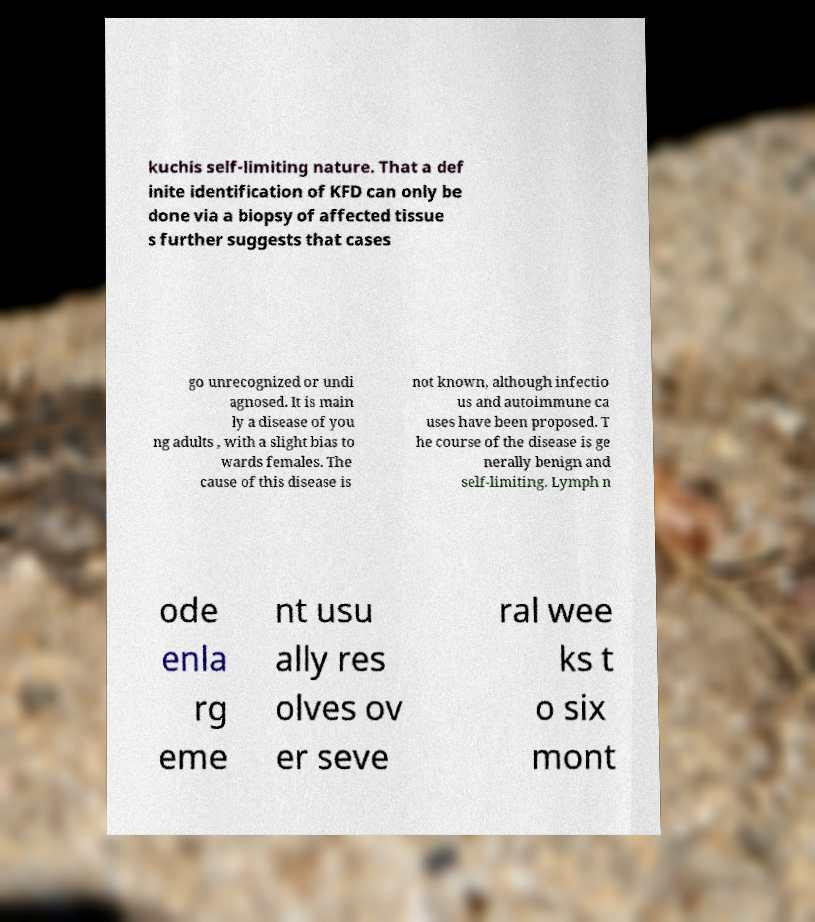Can you read and provide the text displayed in the image?This photo seems to have some interesting text. Can you extract and type it out for me? kuchis self-limiting nature. That a def inite identification of KFD can only be done via a biopsy of affected tissue s further suggests that cases go unrecognized or undi agnosed. It is main ly a disease of you ng adults , with a slight bias to wards females. The cause of this disease is not known, although infectio us and autoimmune ca uses have been proposed. T he course of the disease is ge nerally benign and self-limiting. Lymph n ode enla rg eme nt usu ally res olves ov er seve ral wee ks t o six mont 